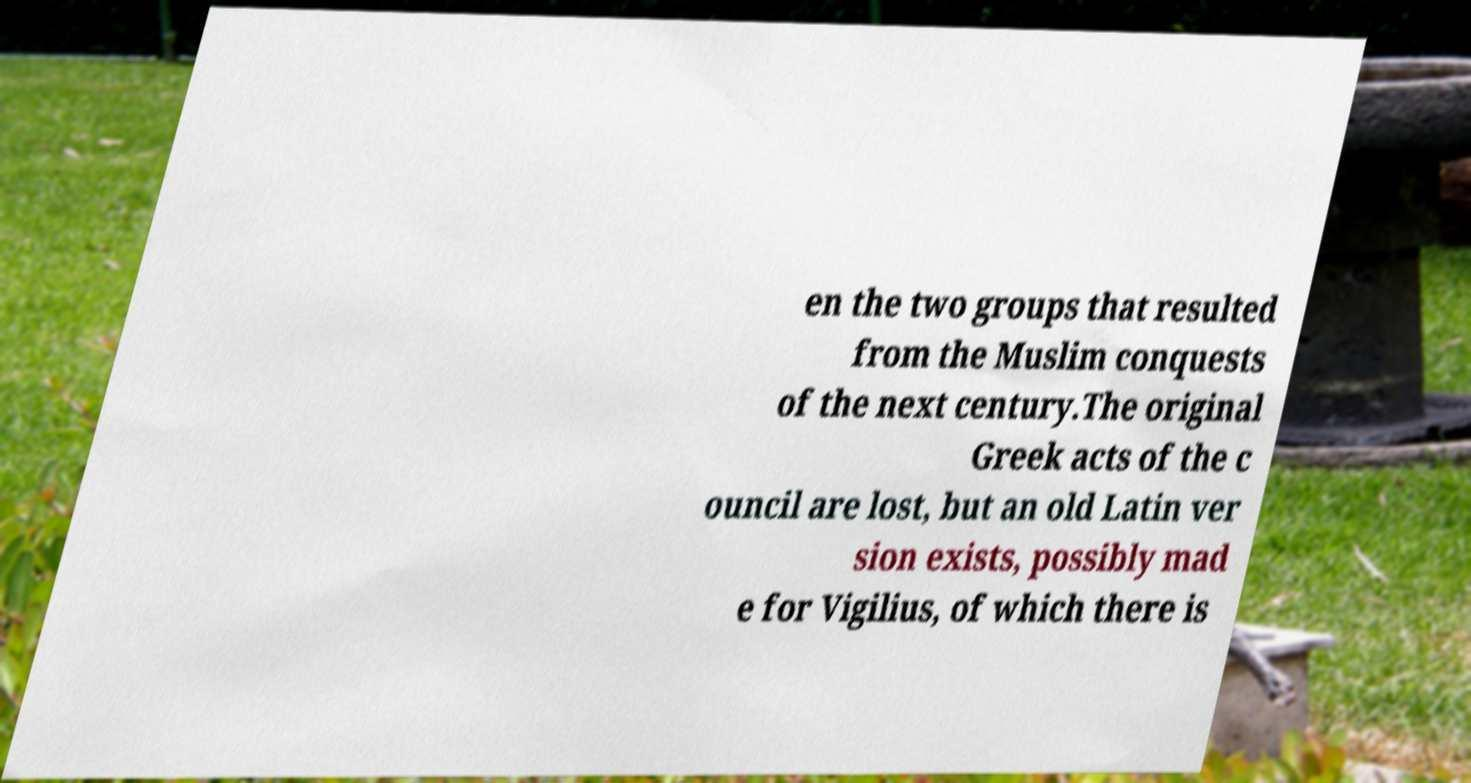I need the written content from this picture converted into text. Can you do that? en the two groups that resulted from the Muslim conquests of the next century.The original Greek acts of the c ouncil are lost, but an old Latin ver sion exists, possibly mad e for Vigilius, of which there is 